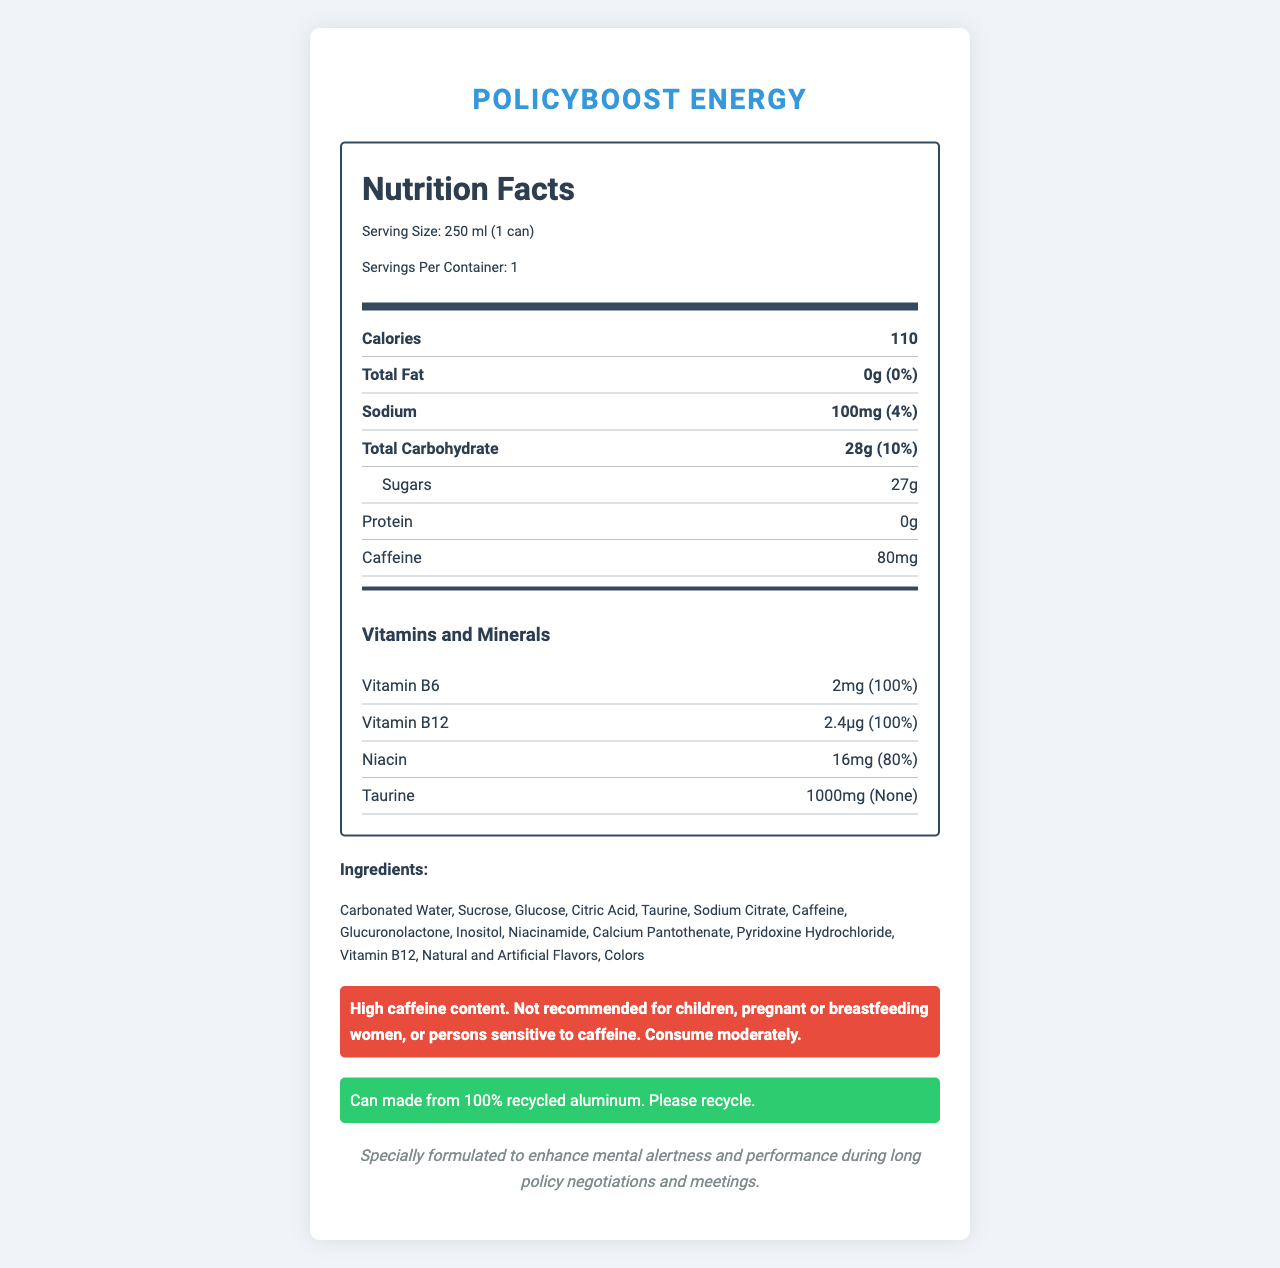What is the serving size of PolicyBoost Energy? The serving size is specified as 250 ml (1 can) in the document.
Answer: 250 ml (1 can) How many calories are in one serving of PolicyBoost Energy? The document states that there are 110 calories per serving.
Answer: 110 What is the amount of caffeine in PolicyBoost Energy? The amount of caffeine is listed as 80mg in the document.
Answer: 80mg What percentage of the daily value of Vitamin B6 does one can of PolicyBoost Energy provide? The document states that one can provides 100% of the daily value of Vitamin B6.
Answer: 100% List three main ingredients in PolicyBoost Energy. The ingredients list begins with Carbonated Water, Sucrose, and Glucose.
Answer: Carbonated Water, Sucrose, Glucose What type of warning is given on the PolicyBoost Energy can? A. Contains alcohol B. Contains artificial sweeteners C. High caffeine content D. High sugar content The warning specifically mentions the high caffeine content as not recommended for certain groups.
Answer: C. High caffeine content What is the daily value of sodium in one serving of PolicyBoost Energy? A. 2% B. 4% C. 6% D. 8% The document states that the daily value of sodium in one serving is 4%.
Answer: B. 4% Which of the following vitamins and minerals does PolicyBoost Energy mainly contain? I. Vitamin C II. Taurine III. Vitamin B12 IV. Calcium The document lists Vitamin B12 and Taurine among the main vitamins and minerals, but not Vitamin C or Calcium.
Answer: II and III Is the product recommended for children or pregnant women? The warning clearly states that the product is not recommended for children, pregnant or breastfeeding women.
Answer: No Summarize the main idea of the document. The document outlines the nutritional content, ingredients, and safety warnings for PolicyBoost Energy, highlighting its energy-boosting components and compliance with relevant regulations.
Answer: The document provides detailed nutrition facts for PolicyBoost Energy, including serving size, calorie content, amounts of various nutrients, and ingredients. Additionally, it includes warnings about high caffeine content and information about the product's sustainability, origin, and regulatory compliance. What is the origin of PolicyBoost Energy? The document states that the product is manufactured in Brussels, Belgium.
Answer: Brussels, Belgium How much Protein does a can of PolicyBoost Energy contain? The document lists 0g of Protein in a serving of PolicyBoost Energy.
Answer: 0g Can the number of servings per container be determined from the document? The document states that there is 1 serving per container.
Answer: Yes, 1 What is the full list of ingredients in PolicyBoost Energy? Although many ingredients are listed, the document states "Natural and Artificial Flavors" and "Colors," which do not provide the exact components.
Answer: Cannot be determined Describe the sustainability note included in the document. The document mentions that the sustainability note highlights the use of 100% recycled aluminum and encourages recycling.
Answer: The can is made from 100% recycled aluminum and emphasizes the importance of recycling. What company manufactures PolicyBoost Energy? The manufacturer is listed as EuroEnergy Beverages Ltd. in the document.
Answer: EuroEnergy Beverages Ltd. 